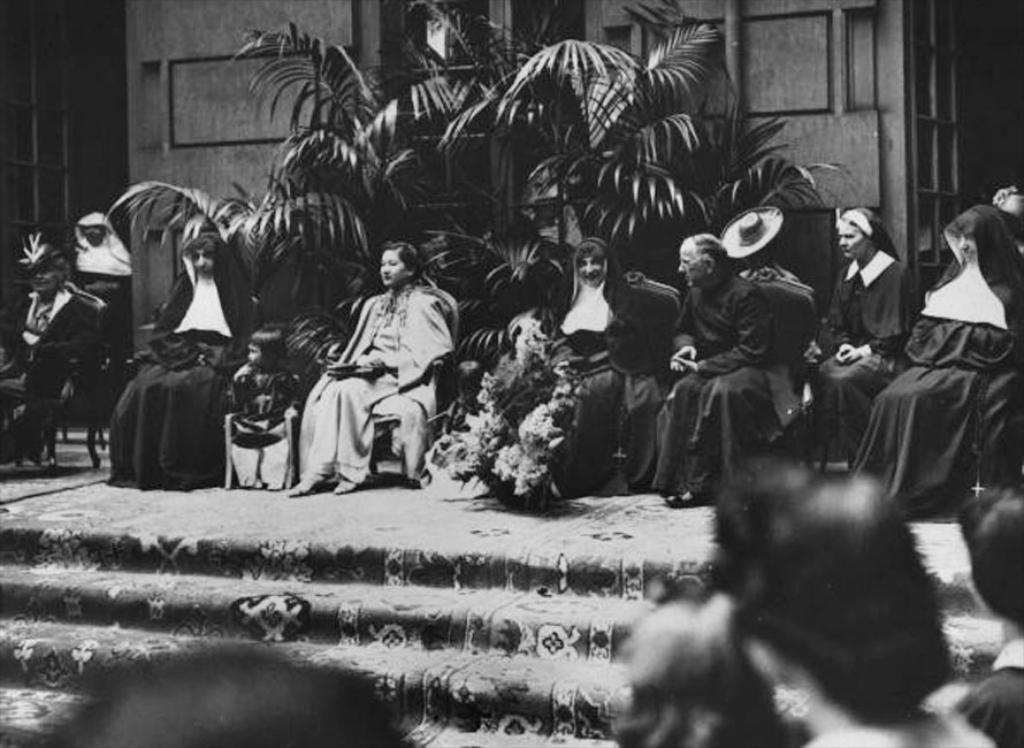Can you describe this image briefly? This is a black and white picture. At the bottom of the picture, we see people are standing. In front of them, we see a staircase. In the middle of the picture, we see people are sitting on the chairs. Behind them, we see plants. In the background, we see a wall and a window. 